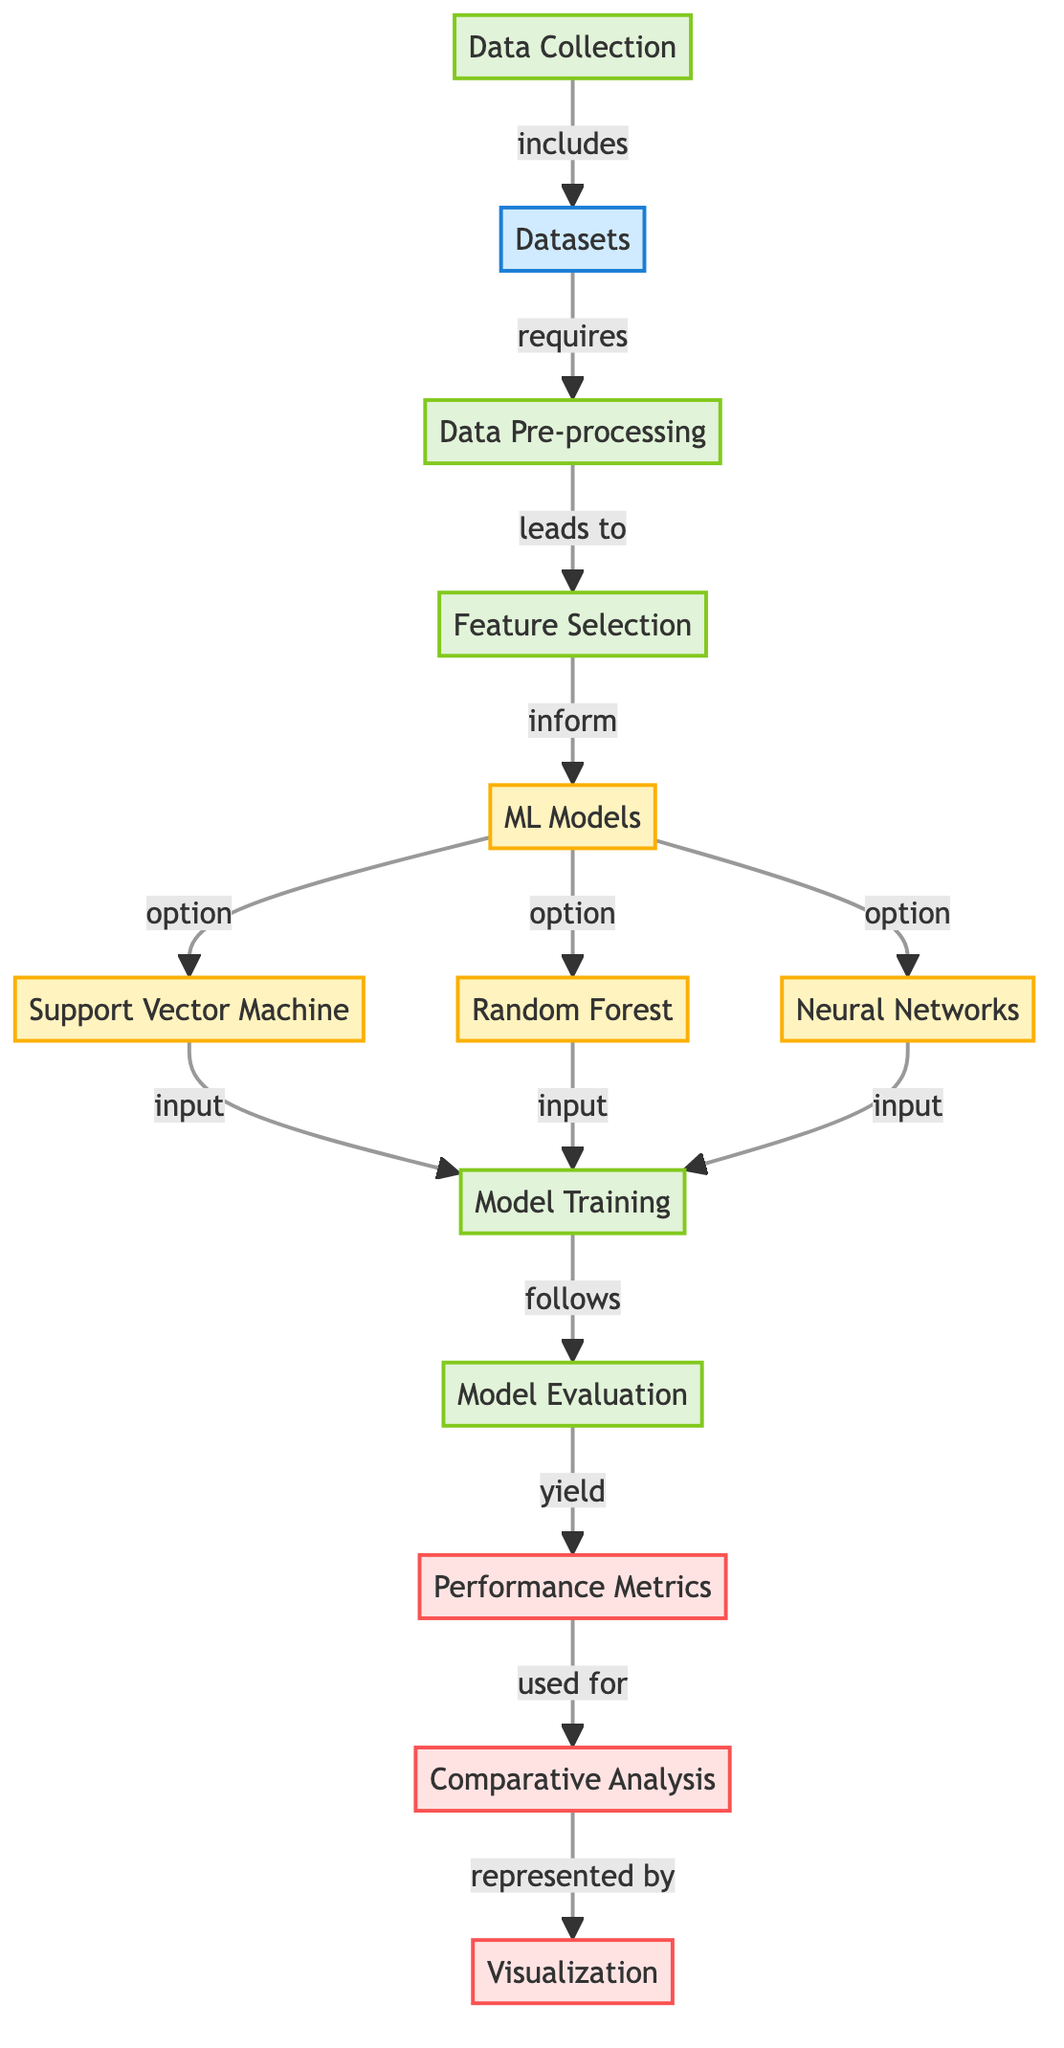What is the first step in the diagram? The diagram indicates that the first step is "Data Collection." This is the initial process that starts before any data manipulation or analysis occurs.
Answer: Data Collection How many machine learning models are included in the diagram? There are three machine learning models mentioned: Support Vector Machine, Random Forest, and Neural Networks. This is derived from the nodes that list these specific models under the "ML Models" category.
Answer: Three What leads from model training to model evaluation? The direct arrow from "Model Training" to "Model Evaluation" signifies that model training is the step that follows before evaluation can occur. This indicates a sequential flow of processes.
Answer: Model Training Which node yields performance metrics? The node "Model Evaluation" is connected by an arrow to "Performance Metrics," which indicates that the evaluation of the models results in the generation of these metrics.
Answer: Model Evaluation What is the final output of the diagram? The diagram suggests that the final output is represented by "Visualization," following the "Comparative Analysis" of the performance metrics. This shows that the analysis leads to a visual representation of results.
Answer: Visualization What type of analysis is performed after performance metrics are obtained? The diagram indicates "Comparative Analysis" is performed after obtaining the performance metrics. This step is specifically for comparing results across different models.
Answer: Comparative Analysis Which node shows the process that informs machine learning models? The "Feature Selection" node is directly connected to the "ML Models," indicating that the features selected in this step are what inform the choice and training of the various models.
Answer: Feature Selection What type of data processing is indicated by the node before feature selection? The node labeled "Data Pre-processing" signifies that some form of data cleaning or transformation occurs prior to feature selection, which is essential for the preparation of the data for analysis.
Answer: Data Pre-processing 